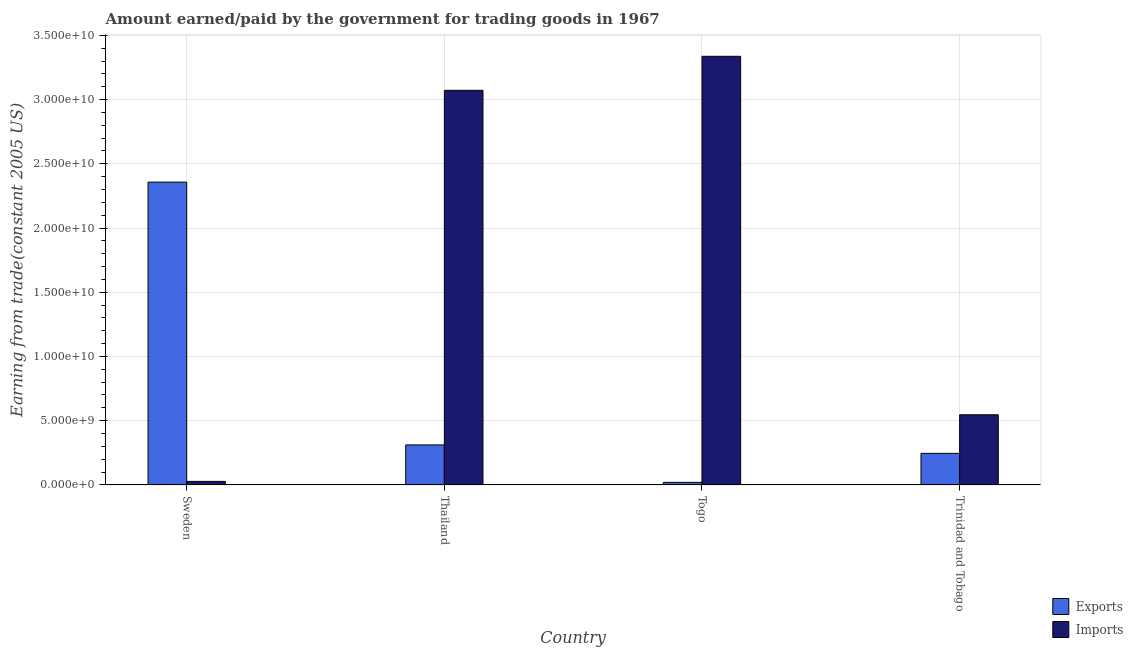How many different coloured bars are there?
Make the answer very short. 2. How many groups of bars are there?
Your answer should be very brief. 4. Are the number of bars per tick equal to the number of legend labels?
Your response must be concise. Yes. Are the number of bars on each tick of the X-axis equal?
Offer a very short reply. Yes. How many bars are there on the 1st tick from the right?
Your answer should be very brief. 2. What is the label of the 2nd group of bars from the left?
Offer a terse response. Thailand. In how many cases, is the number of bars for a given country not equal to the number of legend labels?
Keep it short and to the point. 0. What is the amount earned from exports in Sweden?
Make the answer very short. 2.36e+1. Across all countries, what is the maximum amount earned from exports?
Keep it short and to the point. 2.36e+1. Across all countries, what is the minimum amount earned from exports?
Provide a succinct answer. 1.97e+08. In which country was the amount earned from exports maximum?
Offer a terse response. Sweden. In which country was the amount earned from exports minimum?
Your answer should be compact. Togo. What is the total amount paid for imports in the graph?
Your answer should be compact. 6.98e+1. What is the difference between the amount paid for imports in Togo and that in Trinidad and Tobago?
Ensure brevity in your answer.  2.79e+1. What is the difference between the amount paid for imports in Thailand and the amount earned from exports in Trinidad and Tobago?
Provide a succinct answer. 2.83e+1. What is the average amount earned from exports per country?
Keep it short and to the point. 7.33e+09. What is the difference between the amount paid for imports and amount earned from exports in Trinidad and Tobago?
Keep it short and to the point. 3.00e+09. What is the ratio of the amount earned from exports in Sweden to that in Togo?
Ensure brevity in your answer.  119.81. What is the difference between the highest and the second highest amount paid for imports?
Ensure brevity in your answer.  2.65e+09. What is the difference between the highest and the lowest amount earned from exports?
Give a very brief answer. 2.34e+1. In how many countries, is the amount earned from exports greater than the average amount earned from exports taken over all countries?
Provide a short and direct response. 1. Is the sum of the amount earned from exports in Thailand and Trinidad and Tobago greater than the maximum amount paid for imports across all countries?
Provide a short and direct response. No. What does the 1st bar from the left in Thailand represents?
Give a very brief answer. Exports. What does the 1st bar from the right in Thailand represents?
Offer a terse response. Imports. How many bars are there?
Offer a terse response. 8. Are the values on the major ticks of Y-axis written in scientific E-notation?
Ensure brevity in your answer.  Yes. Does the graph contain any zero values?
Your answer should be compact. No. How many legend labels are there?
Make the answer very short. 2. How are the legend labels stacked?
Give a very brief answer. Vertical. What is the title of the graph?
Your response must be concise. Amount earned/paid by the government for trading goods in 1967. What is the label or title of the Y-axis?
Provide a short and direct response. Earning from trade(constant 2005 US). What is the Earning from trade(constant 2005 US) of Exports in Sweden?
Offer a very short reply. 2.36e+1. What is the Earning from trade(constant 2005 US) in Imports in Sweden?
Offer a very short reply. 2.72e+08. What is the Earning from trade(constant 2005 US) in Exports in Thailand?
Your answer should be compact. 3.11e+09. What is the Earning from trade(constant 2005 US) of Imports in Thailand?
Make the answer very short. 3.07e+1. What is the Earning from trade(constant 2005 US) of Exports in Togo?
Your answer should be very brief. 1.97e+08. What is the Earning from trade(constant 2005 US) of Imports in Togo?
Make the answer very short. 3.34e+1. What is the Earning from trade(constant 2005 US) of Exports in Trinidad and Tobago?
Give a very brief answer. 2.45e+09. What is the Earning from trade(constant 2005 US) in Imports in Trinidad and Tobago?
Provide a succinct answer. 5.46e+09. Across all countries, what is the maximum Earning from trade(constant 2005 US) in Exports?
Provide a succinct answer. 2.36e+1. Across all countries, what is the maximum Earning from trade(constant 2005 US) in Imports?
Give a very brief answer. 3.34e+1. Across all countries, what is the minimum Earning from trade(constant 2005 US) in Exports?
Make the answer very short. 1.97e+08. Across all countries, what is the minimum Earning from trade(constant 2005 US) in Imports?
Provide a short and direct response. 2.72e+08. What is the total Earning from trade(constant 2005 US) of Exports in the graph?
Give a very brief answer. 2.93e+1. What is the total Earning from trade(constant 2005 US) in Imports in the graph?
Ensure brevity in your answer.  6.98e+1. What is the difference between the Earning from trade(constant 2005 US) of Exports in Sweden and that in Thailand?
Make the answer very short. 2.05e+1. What is the difference between the Earning from trade(constant 2005 US) in Imports in Sweden and that in Thailand?
Offer a very short reply. -3.04e+1. What is the difference between the Earning from trade(constant 2005 US) of Exports in Sweden and that in Togo?
Your response must be concise. 2.34e+1. What is the difference between the Earning from trade(constant 2005 US) in Imports in Sweden and that in Togo?
Your response must be concise. -3.31e+1. What is the difference between the Earning from trade(constant 2005 US) in Exports in Sweden and that in Trinidad and Tobago?
Provide a succinct answer. 2.11e+1. What is the difference between the Earning from trade(constant 2005 US) in Imports in Sweden and that in Trinidad and Tobago?
Ensure brevity in your answer.  -5.19e+09. What is the difference between the Earning from trade(constant 2005 US) of Exports in Thailand and that in Togo?
Your response must be concise. 2.91e+09. What is the difference between the Earning from trade(constant 2005 US) of Imports in Thailand and that in Togo?
Ensure brevity in your answer.  -2.65e+09. What is the difference between the Earning from trade(constant 2005 US) of Exports in Thailand and that in Trinidad and Tobago?
Your answer should be very brief. 6.57e+08. What is the difference between the Earning from trade(constant 2005 US) in Imports in Thailand and that in Trinidad and Tobago?
Make the answer very short. 2.53e+1. What is the difference between the Earning from trade(constant 2005 US) of Exports in Togo and that in Trinidad and Tobago?
Give a very brief answer. -2.26e+09. What is the difference between the Earning from trade(constant 2005 US) in Imports in Togo and that in Trinidad and Tobago?
Provide a succinct answer. 2.79e+1. What is the difference between the Earning from trade(constant 2005 US) in Exports in Sweden and the Earning from trade(constant 2005 US) in Imports in Thailand?
Your answer should be compact. -7.15e+09. What is the difference between the Earning from trade(constant 2005 US) of Exports in Sweden and the Earning from trade(constant 2005 US) of Imports in Togo?
Ensure brevity in your answer.  -9.80e+09. What is the difference between the Earning from trade(constant 2005 US) in Exports in Sweden and the Earning from trade(constant 2005 US) in Imports in Trinidad and Tobago?
Offer a terse response. 1.81e+1. What is the difference between the Earning from trade(constant 2005 US) of Exports in Thailand and the Earning from trade(constant 2005 US) of Imports in Togo?
Your answer should be very brief. -3.03e+1. What is the difference between the Earning from trade(constant 2005 US) in Exports in Thailand and the Earning from trade(constant 2005 US) in Imports in Trinidad and Tobago?
Your answer should be very brief. -2.35e+09. What is the difference between the Earning from trade(constant 2005 US) of Exports in Togo and the Earning from trade(constant 2005 US) of Imports in Trinidad and Tobago?
Provide a succinct answer. -5.26e+09. What is the average Earning from trade(constant 2005 US) in Exports per country?
Keep it short and to the point. 7.33e+09. What is the average Earning from trade(constant 2005 US) of Imports per country?
Make the answer very short. 1.75e+1. What is the difference between the Earning from trade(constant 2005 US) in Exports and Earning from trade(constant 2005 US) in Imports in Sweden?
Give a very brief answer. 2.33e+1. What is the difference between the Earning from trade(constant 2005 US) of Exports and Earning from trade(constant 2005 US) of Imports in Thailand?
Keep it short and to the point. -2.76e+1. What is the difference between the Earning from trade(constant 2005 US) in Exports and Earning from trade(constant 2005 US) in Imports in Togo?
Provide a short and direct response. -3.32e+1. What is the difference between the Earning from trade(constant 2005 US) of Exports and Earning from trade(constant 2005 US) of Imports in Trinidad and Tobago?
Make the answer very short. -3.00e+09. What is the ratio of the Earning from trade(constant 2005 US) in Exports in Sweden to that in Thailand?
Provide a succinct answer. 7.58. What is the ratio of the Earning from trade(constant 2005 US) in Imports in Sweden to that in Thailand?
Offer a very short reply. 0.01. What is the ratio of the Earning from trade(constant 2005 US) in Exports in Sweden to that in Togo?
Your answer should be compact. 119.81. What is the ratio of the Earning from trade(constant 2005 US) of Imports in Sweden to that in Togo?
Your response must be concise. 0.01. What is the ratio of the Earning from trade(constant 2005 US) in Exports in Sweden to that in Trinidad and Tobago?
Your answer should be compact. 9.6. What is the ratio of the Earning from trade(constant 2005 US) in Imports in Sweden to that in Trinidad and Tobago?
Keep it short and to the point. 0.05. What is the ratio of the Earning from trade(constant 2005 US) of Exports in Thailand to that in Togo?
Your response must be concise. 15.81. What is the ratio of the Earning from trade(constant 2005 US) of Imports in Thailand to that in Togo?
Offer a terse response. 0.92. What is the ratio of the Earning from trade(constant 2005 US) in Exports in Thailand to that in Trinidad and Tobago?
Your answer should be very brief. 1.27. What is the ratio of the Earning from trade(constant 2005 US) of Imports in Thailand to that in Trinidad and Tobago?
Your answer should be compact. 5.63. What is the ratio of the Earning from trade(constant 2005 US) in Exports in Togo to that in Trinidad and Tobago?
Give a very brief answer. 0.08. What is the ratio of the Earning from trade(constant 2005 US) in Imports in Togo to that in Trinidad and Tobago?
Your answer should be compact. 6.11. What is the difference between the highest and the second highest Earning from trade(constant 2005 US) in Exports?
Make the answer very short. 2.05e+1. What is the difference between the highest and the second highest Earning from trade(constant 2005 US) in Imports?
Provide a short and direct response. 2.65e+09. What is the difference between the highest and the lowest Earning from trade(constant 2005 US) in Exports?
Ensure brevity in your answer.  2.34e+1. What is the difference between the highest and the lowest Earning from trade(constant 2005 US) in Imports?
Your answer should be compact. 3.31e+1. 